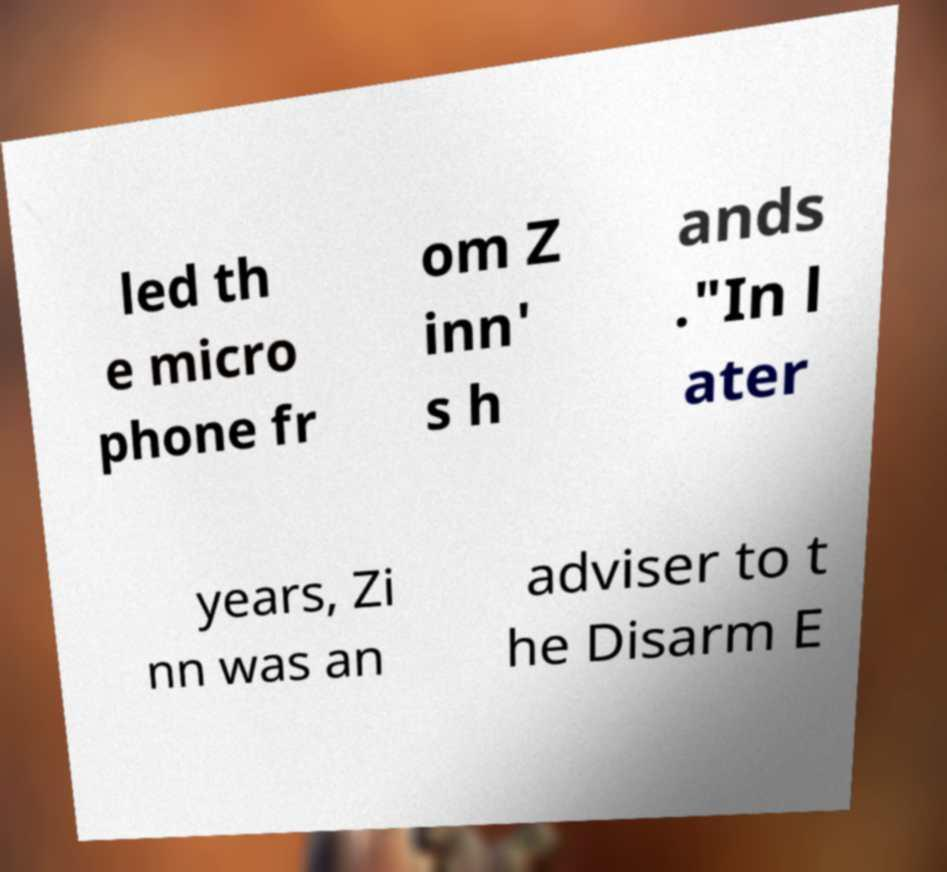I need the written content from this picture converted into text. Can you do that? led th e micro phone fr om Z inn' s h ands ."In l ater years, Zi nn was an adviser to t he Disarm E 